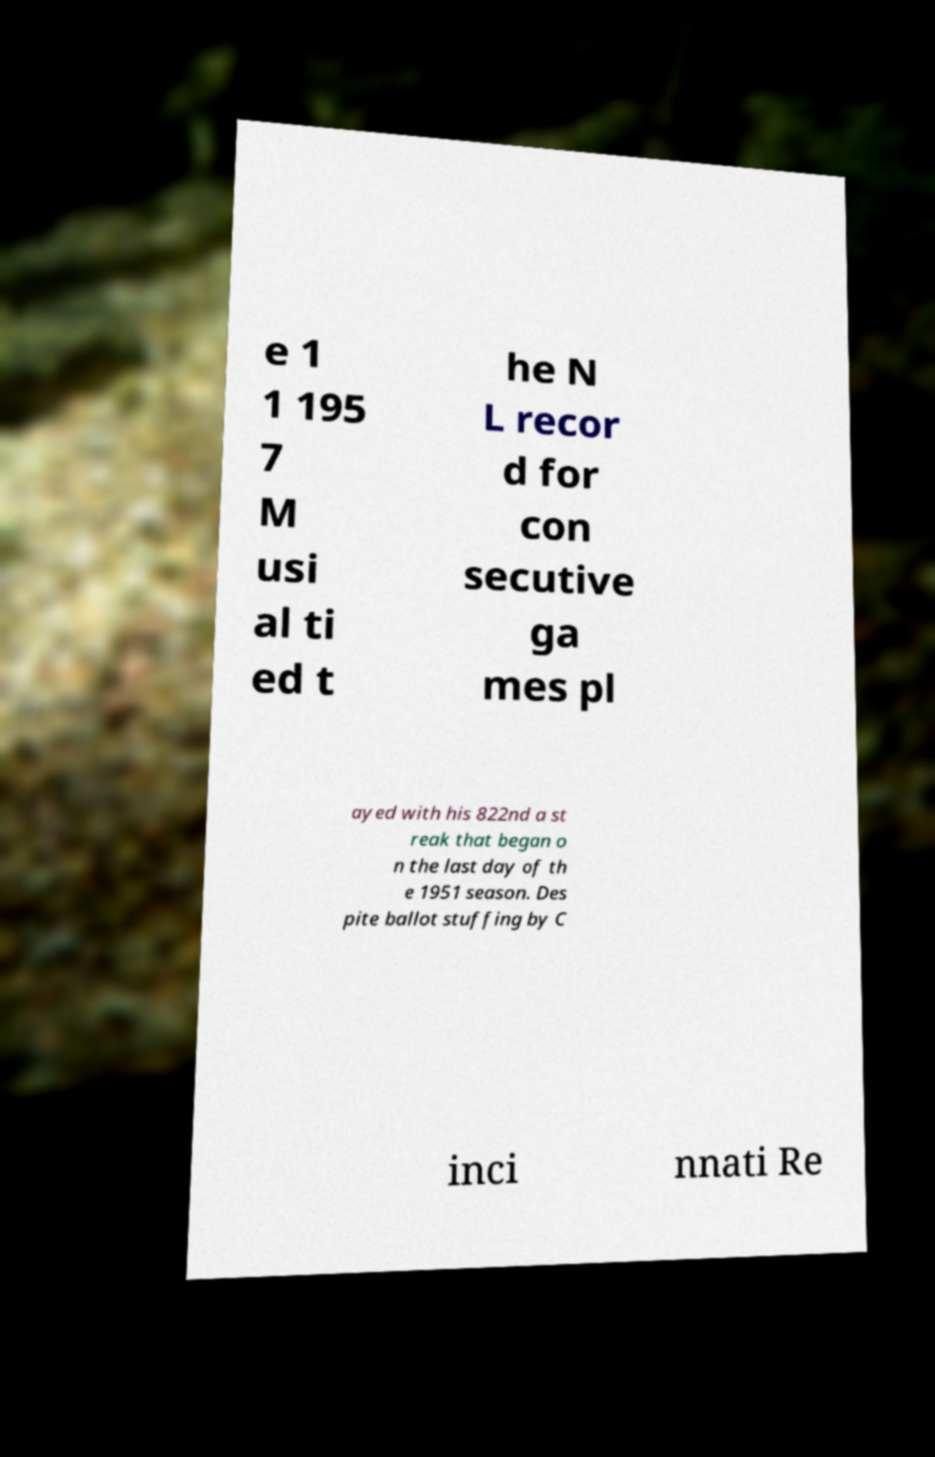There's text embedded in this image that I need extracted. Can you transcribe it verbatim? e 1 1 195 7 M usi al ti ed t he N L recor d for con secutive ga mes pl ayed with his 822nd a st reak that began o n the last day of th e 1951 season. Des pite ballot stuffing by C inci nnati Re 